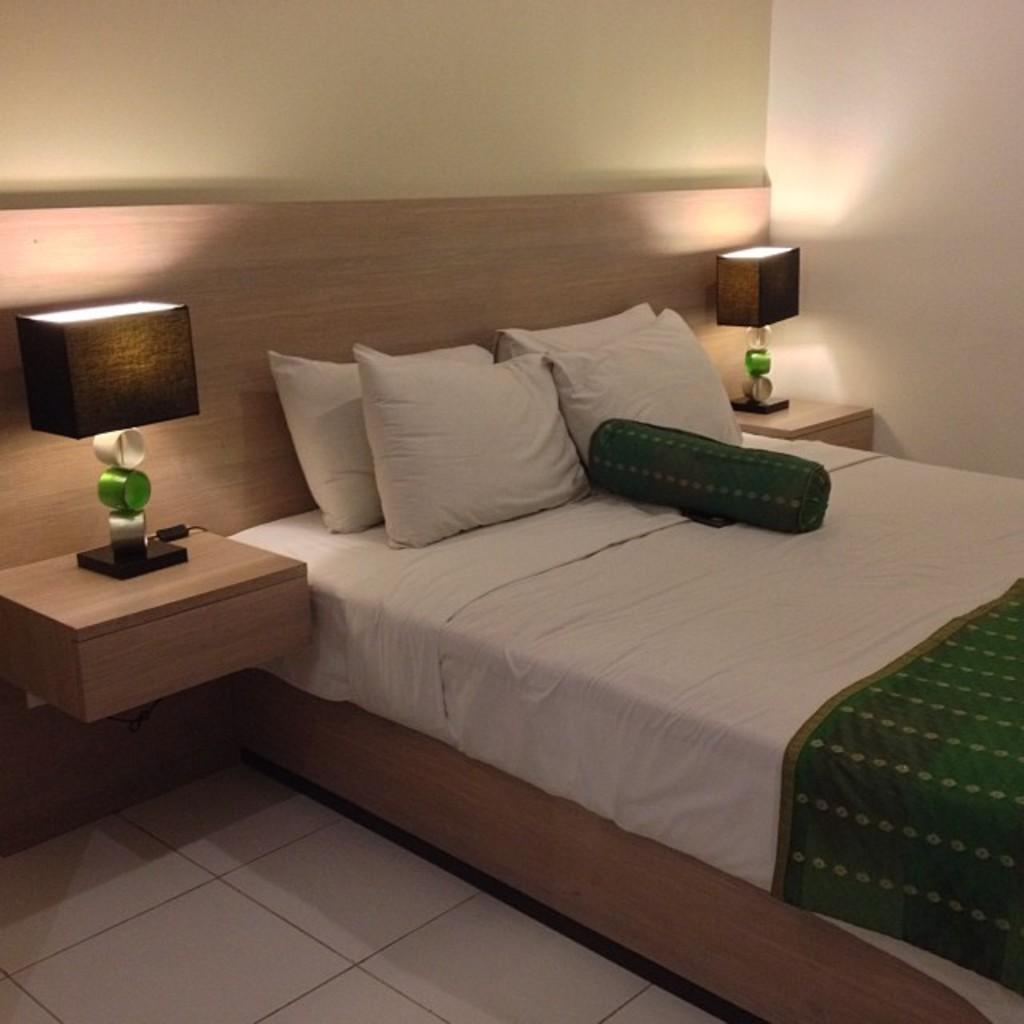What piece of furniture is present in the image? There is a bed in the image. What is placed on the bed? There are pillows on the bed. What type of lighting is present near the bed? There are lamps on either side of the bed. What can be seen in the background of the image? There is a wall visible in the background of the image. What is the purpose of the snail in the image? There is no snail present in the image, so it cannot serve any purpose. 